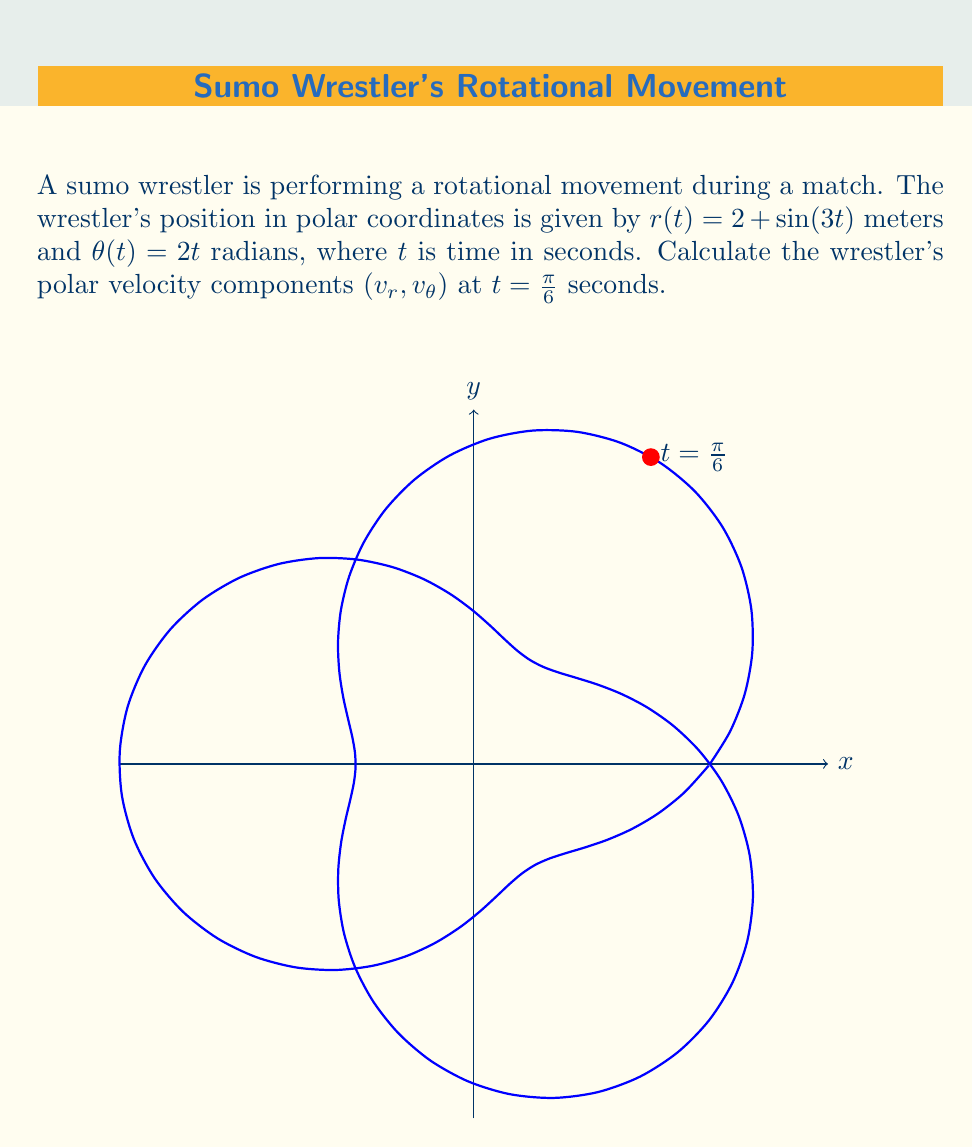Show me your answer to this math problem. To solve this problem, we'll use the polar velocity equations:

1) $v_r = \frac{dr}{dt}$
2) $v_\theta = r\frac{d\theta}{dt}$

Step 1: Calculate $v_r$
$$\frac{dr}{dt} = \frac{d}{dt}[2 + \sin(3t)] = 3\cos(3t)$$

At $t = \frac{\pi}{6}$:
$$v_r = 3\cos(3\cdot\frac{\pi}{6}) = 3\cos(\frac{\pi}{2}) = 0$$

Step 2: Calculate $v_\theta$
First, we need $r$ at $t = \frac{\pi}{6}$:
$$r(\frac{\pi}{6}) = 2 + \sin(3\cdot\frac{\pi}{6}) = 2 + \sin(\frac{\pi}{2}) = 3$$

Now, $\frac{d\theta}{dt} = \frac{d}{dt}(2t) = 2$

Therefore:
$$v_\theta = r\frac{d\theta}{dt} = 3 \cdot 2 = 6$$

Step 3: Combine the results
The polar velocity components at $t = \frac{\pi}{6}$ are $(v_r, v_\theta) = (0, 6)$.
Answer: $(0, 6)$ m/s 